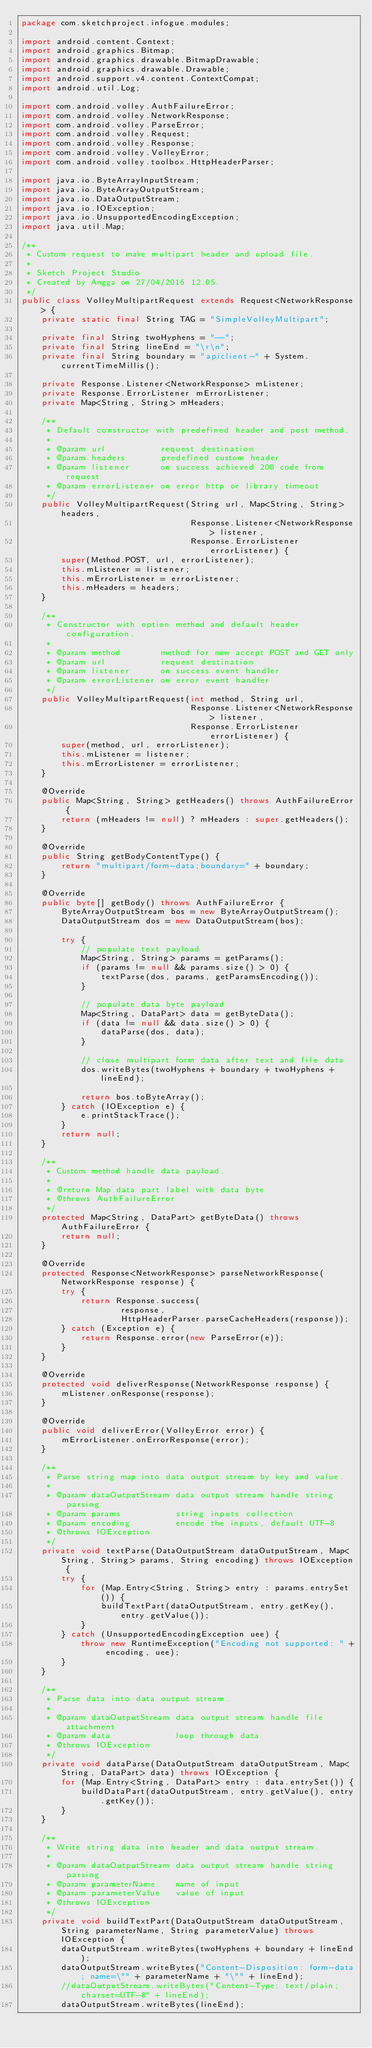<code> <loc_0><loc_0><loc_500><loc_500><_Java_>package com.sketchproject.infogue.modules;

import android.content.Context;
import android.graphics.Bitmap;
import android.graphics.drawable.BitmapDrawable;
import android.graphics.drawable.Drawable;
import android.support.v4.content.ContextCompat;
import android.util.Log;

import com.android.volley.AuthFailureError;
import com.android.volley.NetworkResponse;
import com.android.volley.ParseError;
import com.android.volley.Request;
import com.android.volley.Response;
import com.android.volley.VolleyError;
import com.android.volley.toolbox.HttpHeaderParser;

import java.io.ByteArrayInputStream;
import java.io.ByteArrayOutputStream;
import java.io.DataOutputStream;
import java.io.IOException;
import java.io.UnsupportedEncodingException;
import java.util.Map;

/**
 * Custom request to make multipart header and upload file.
 *
 * Sketch Project Studio
 * Created by Angga on 27/04/2016 12.05.
 */
public class VolleyMultipartRequest extends Request<NetworkResponse> {
    private static final String TAG = "SimpleVolleyMultipart";

    private final String twoHyphens = "--";
    private final String lineEnd = "\r\n";
    private final String boundary = "apiclient-" + System.currentTimeMillis();

    private Response.Listener<NetworkResponse> mListener;
    private Response.ErrorListener mErrorListener;
    private Map<String, String> mHeaders;

    /**
     * Default constructor with predefined header and post method.
     *
     * @param url           request destination
     * @param headers       predefined custom header
     * @param listener      on success achieved 200 code from request
     * @param errorListener on error http or library timeout
     */
    public VolleyMultipartRequest(String url, Map<String, String> headers,
                                  Response.Listener<NetworkResponse> listener,
                                  Response.ErrorListener errorListener) {
        super(Method.POST, url, errorListener);
        this.mListener = listener;
        this.mErrorListener = errorListener;
        this.mHeaders = headers;
    }

    /**
     * Constructor with option method and default header configuration.
     *
     * @param method        method for now accept POST and GET only
     * @param url           request destination
     * @param listener      on success event handler
     * @param errorListener on error event handler
     */
    public VolleyMultipartRequest(int method, String url,
                                  Response.Listener<NetworkResponse> listener,
                                  Response.ErrorListener errorListener) {
        super(method, url, errorListener);
        this.mListener = listener;
        this.mErrorListener = errorListener;
    }

    @Override
    public Map<String, String> getHeaders() throws AuthFailureError {
        return (mHeaders != null) ? mHeaders : super.getHeaders();
    }

    @Override
    public String getBodyContentType() {
        return "multipart/form-data;boundary=" + boundary;
    }

    @Override
    public byte[] getBody() throws AuthFailureError {
        ByteArrayOutputStream bos = new ByteArrayOutputStream();
        DataOutputStream dos = new DataOutputStream(bos);

        try {
            // populate text payload
            Map<String, String> params = getParams();
            if (params != null && params.size() > 0) {
                textParse(dos, params, getParamsEncoding());
            }

            // populate data byte payload
            Map<String, DataPart> data = getByteData();
            if (data != null && data.size() > 0) {
                dataParse(dos, data);
            }

            // close multipart form data after text and file data
            dos.writeBytes(twoHyphens + boundary + twoHyphens + lineEnd);

            return bos.toByteArray();
        } catch (IOException e) {
            e.printStackTrace();
        }
        return null;
    }

    /**
     * Custom method handle data payload.
     *
     * @return Map data part label with data byte
     * @throws AuthFailureError
     */
    protected Map<String, DataPart> getByteData() throws AuthFailureError {
        return null;
    }

    @Override
    protected Response<NetworkResponse> parseNetworkResponse(NetworkResponse response) {
        try {
            return Response.success(
                    response,
                    HttpHeaderParser.parseCacheHeaders(response));
        } catch (Exception e) {
            return Response.error(new ParseError(e));
        }
    }

    @Override
    protected void deliverResponse(NetworkResponse response) {
        mListener.onResponse(response);
    }

    @Override
    public void deliverError(VolleyError error) {
        mErrorListener.onErrorResponse(error);
    }

    /**
     * Parse string map into data output stream by key and value.
     *
     * @param dataOutputStream data output stream handle string parsing
     * @param params           string inputs collection
     * @param encoding         encode the inputs, default UTF-8
     * @throws IOException
     */
    private void textParse(DataOutputStream dataOutputStream, Map<String, String> params, String encoding) throws IOException {
        try {
            for (Map.Entry<String, String> entry : params.entrySet()) {
                buildTextPart(dataOutputStream, entry.getKey(), entry.getValue());
            }
        } catch (UnsupportedEncodingException uee) {
            throw new RuntimeException("Encoding not supported: " + encoding, uee);
        }
    }

    /**
     * Parse data into data output stream.
     *
     * @param dataOutputStream data output stream handle file attachment
     * @param data             loop through data
     * @throws IOException
     */
    private void dataParse(DataOutputStream dataOutputStream, Map<String, DataPart> data) throws IOException {
        for (Map.Entry<String, DataPart> entry : data.entrySet()) {
            buildDataPart(dataOutputStream, entry.getValue(), entry.getKey());
        }
    }

    /**
     * Write string data into header and data output stream.
     *
     * @param dataOutputStream data output stream handle string parsing
     * @param parameterName    name of input
     * @param parameterValue   value of input
     * @throws IOException
     */
    private void buildTextPart(DataOutputStream dataOutputStream, String parameterName, String parameterValue) throws IOException {
        dataOutputStream.writeBytes(twoHyphens + boundary + lineEnd);
        dataOutputStream.writeBytes("Content-Disposition: form-data; name=\"" + parameterName + "\"" + lineEnd);
        //dataOutputStream.writeBytes("Content-Type: text/plain; charset=UTF-8" + lineEnd);
        dataOutputStream.writeBytes(lineEnd);</code> 